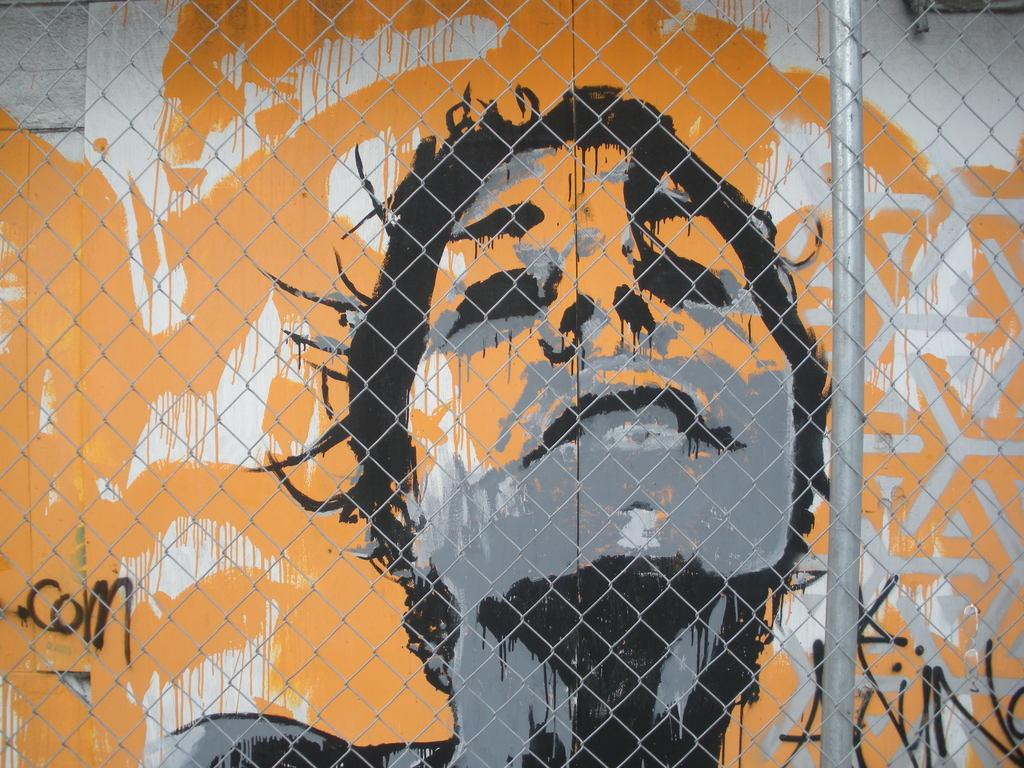What is hanging on the wall in the image? There is a painting on the wall in the image. What type of structure can be seen in the image? There is a fence in the image. How many dogs are sitting on the fence in the image? There are no dogs visible in the image; it only features a painting on the wall and a fence. What type of jar is placed on the fence in the image? There is no jar visible in the image; it only features a painting on the wall and a fence. 